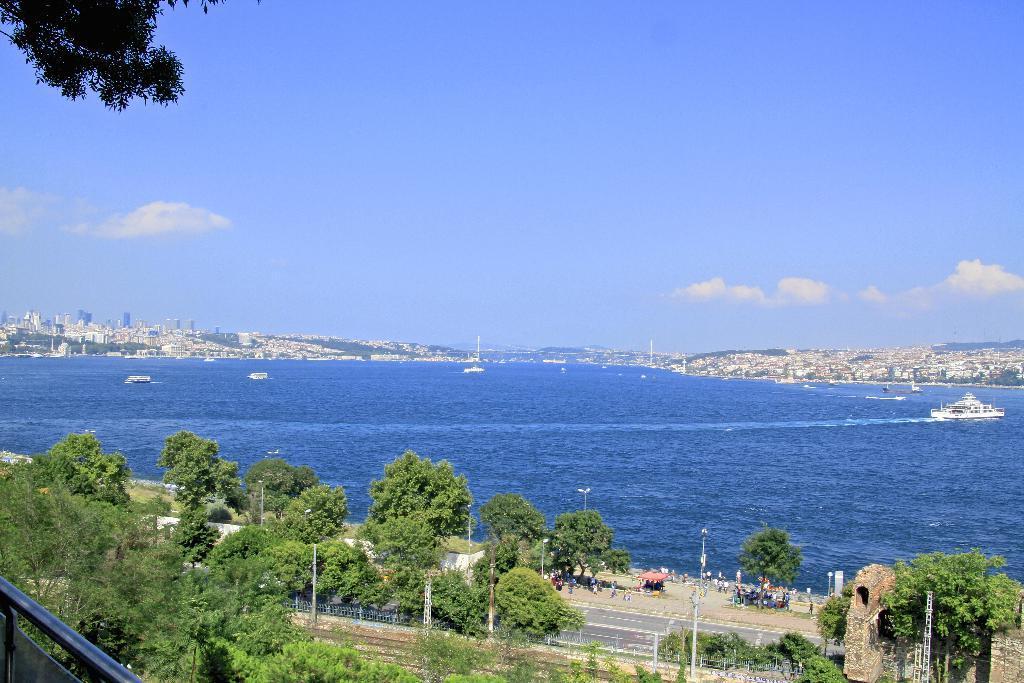In one or two sentences, can you explain what this image depicts? As we can see in the image there are few trees, road and water. In the background there are few buildings. 